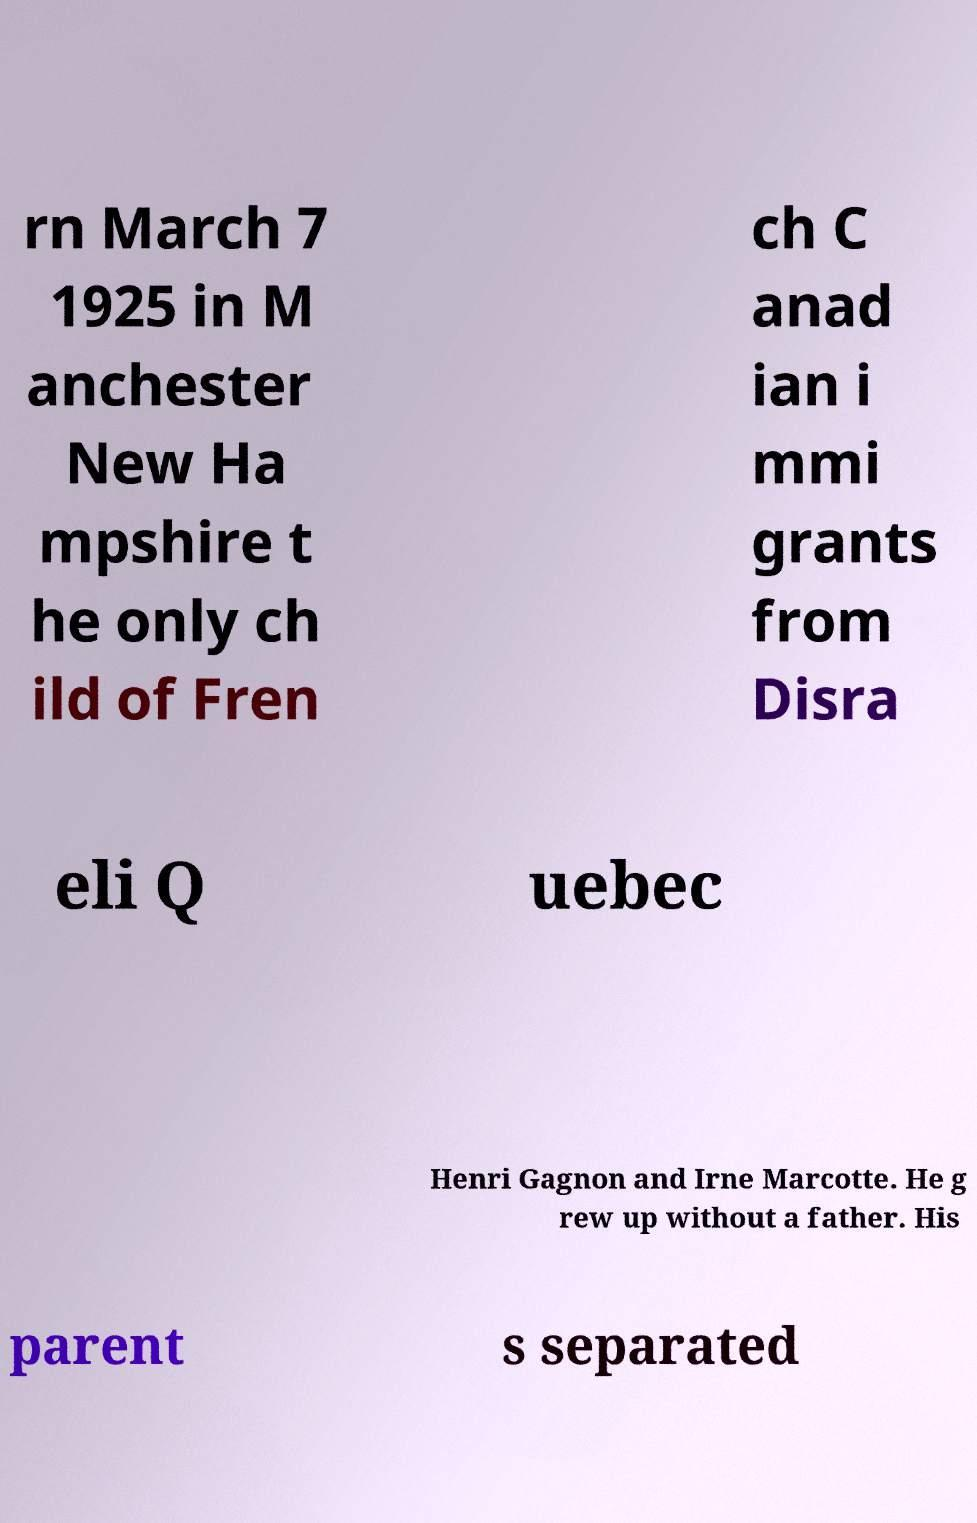Could you assist in decoding the text presented in this image and type it out clearly? rn March 7 1925 in M anchester New Ha mpshire t he only ch ild of Fren ch C anad ian i mmi grants from Disra eli Q uebec Henri Gagnon and Irne Marcotte. He g rew up without a father. His parent s separated 